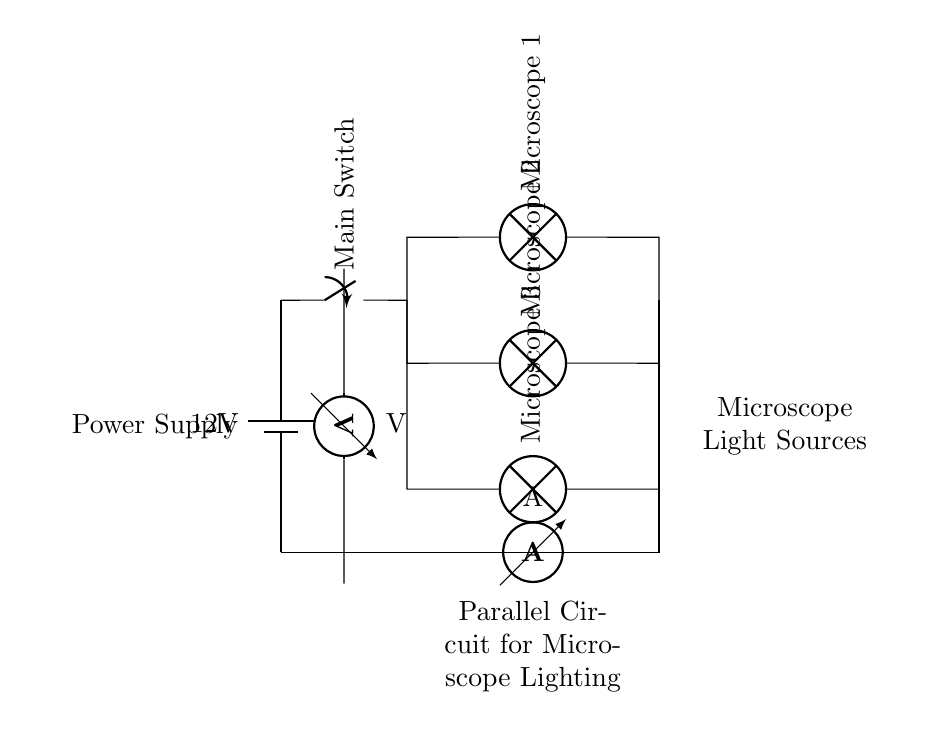What is the voltage of this circuit? The voltage of the circuit is 12 volts, as indicated by the battery symbol showing a potential difference.
Answer: 12 volts What does the main switch do? The main switch controls the flow of current in the entire circuit, allowing or stopping power to all connected devices when toggled.
Answer: Control power flow How many microscope light sources are there? There are three microscope light sources connected in parallel, each represented by a lamp in the diagram.
Answer: Three What is the function of the ammeter in this circuit? The ammeter measures the current flowing through the circuit, which is essential for assessing the overall electrical consumption.
Answer: Measure current What type of circuit arrangement is depicted in this diagram? The diagram depicts a parallel circuit arrangement, where each microscope light source is connected independently to the power supply.
Answer: Parallel circuit What happens if one light source fails? If one light source fails, the other light sources will remain operational because they are connected in parallel, allowing current to flow through the remaining branches.
Answer: Others remain operational What is the current flowing through the circuit indicated by the ammeter? The specific current value is not indicated on the diagram, but it will vary based on the resistance of the light sources and the total voltage applied.
Answer: Not specified 